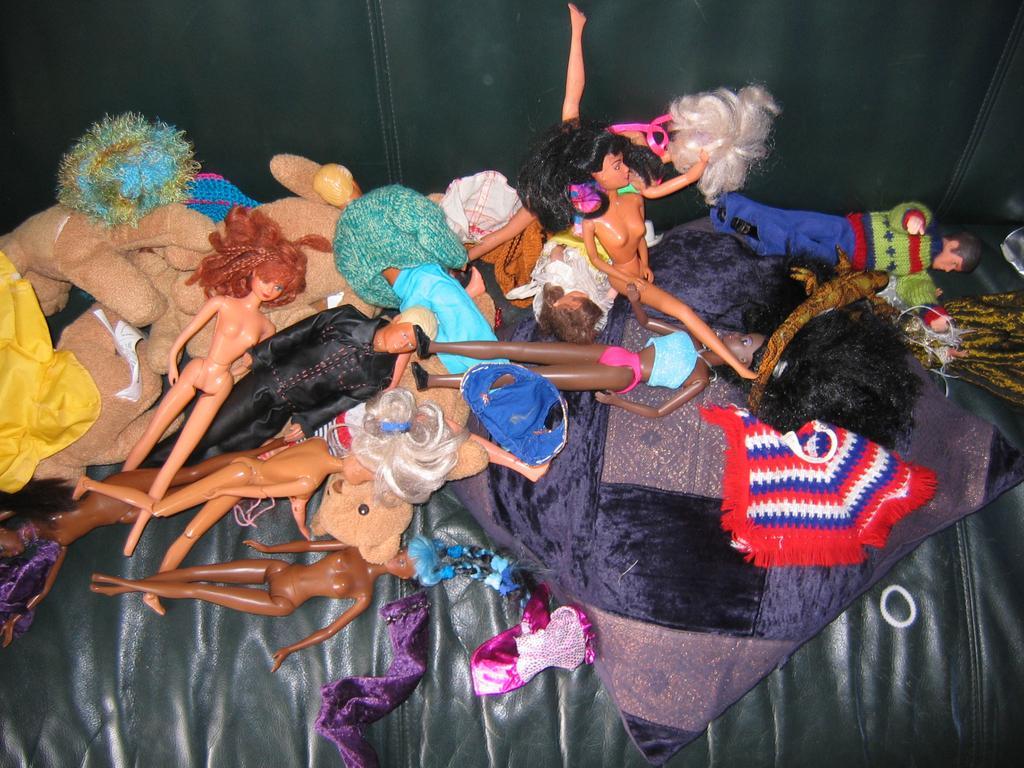Please provide a concise description of this image. In the image we can see there are many toys of different colors and shape. The toys are kept of the sofa. There is even a pillow, on the sofa. 